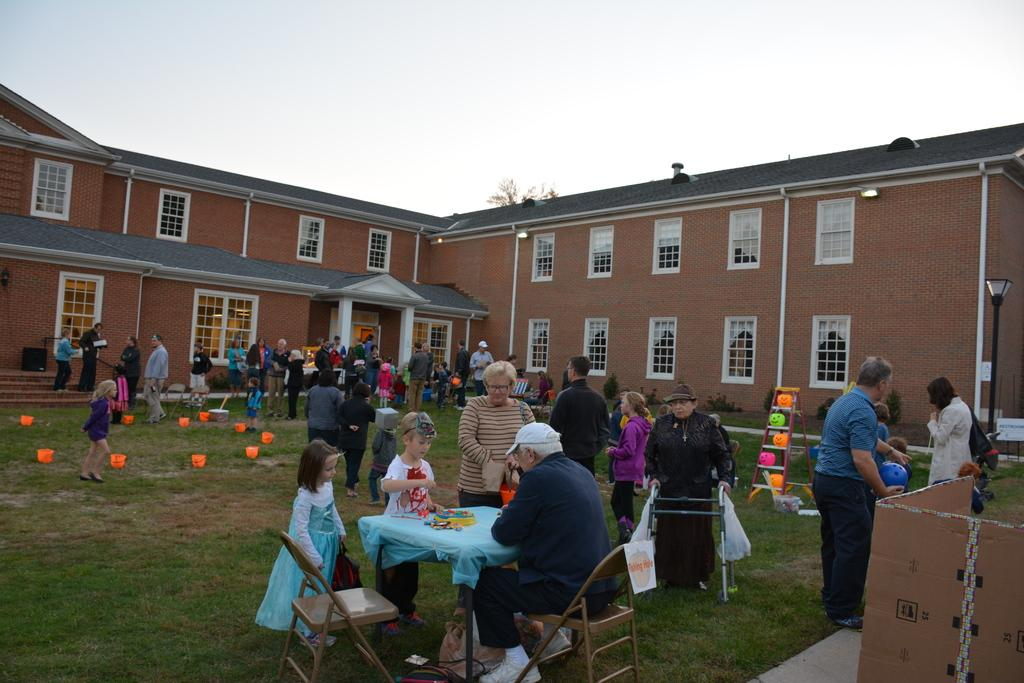How many people are in the image? There are many people in the image. Where are the people located in the image? The people are on the ground. What objects are in the foreground of the image? There is a table and chairs in the foreground of the image. What can be seen in the background of the image? There is a building and the sky visible in the background of the image. How does the fireman move the woman in the image? There is no fireman or woman present in the image. What type of move does the woman perform in the image? There is no woman present in the image, and therefore no move can be observed. 